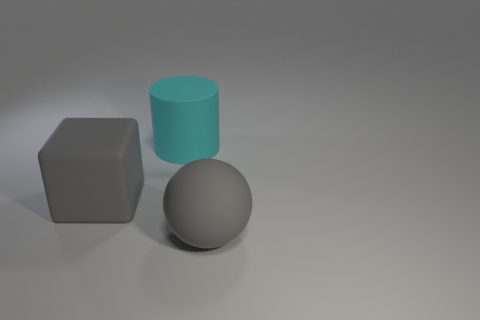Is there another large cube that has the same color as the cube?
Provide a succinct answer. No. There is a cyan rubber thing that is the same size as the cube; what shape is it?
Ensure brevity in your answer.  Cylinder. There is a big object that is on the left side of the large cylinder; is its color the same as the big sphere?
Provide a short and direct response. Yes. How many things are gray objects that are left of the large gray rubber sphere or cyan objects?
Offer a terse response. 2. Is the number of rubber things that are to the left of the big ball greater than the number of large gray blocks right of the big cyan object?
Offer a terse response. Yes. Is the material of the ball the same as the large cylinder?
Provide a short and direct response. Yes. There is a large thing that is to the right of the gray rubber block and in front of the cyan rubber cylinder; what is its shape?
Your answer should be compact. Sphere. What is the shape of the gray object that is made of the same material as the ball?
Offer a terse response. Cube. Is there a small blue matte object?
Your answer should be very brief. No. There is a big rubber thing that is in front of the big block; are there any large matte objects that are right of it?
Keep it short and to the point. No. 